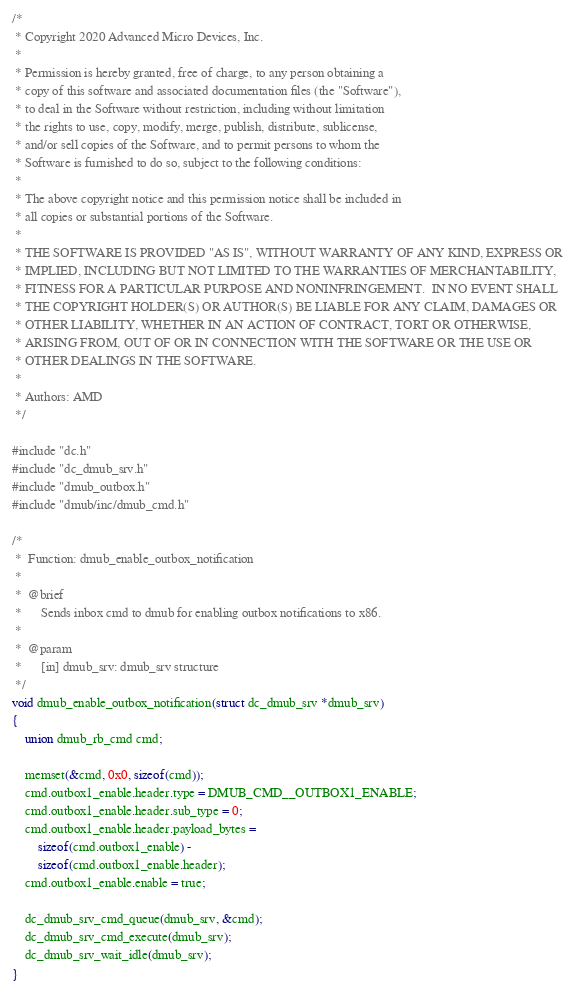<code> <loc_0><loc_0><loc_500><loc_500><_C_>/*
 * Copyright 2020 Advanced Micro Devices, Inc.
 *
 * Permission is hereby granted, free of charge, to any person obtaining a
 * copy of this software and associated documentation files (the "Software"),
 * to deal in the Software without restriction, including without limitation
 * the rights to use, copy, modify, merge, publish, distribute, sublicense,
 * and/or sell copies of the Software, and to permit persons to whom the
 * Software is furnished to do so, subject to the following conditions:
 *
 * The above copyright notice and this permission notice shall be included in
 * all copies or substantial portions of the Software.
 *
 * THE SOFTWARE IS PROVIDED "AS IS", WITHOUT WARRANTY OF ANY KIND, EXPRESS OR
 * IMPLIED, INCLUDING BUT NOT LIMITED TO THE WARRANTIES OF MERCHANTABILITY,
 * FITNESS FOR A PARTICULAR PURPOSE AND NONINFRINGEMENT.  IN NO EVENT SHALL
 * THE COPYRIGHT HOLDER(S) OR AUTHOR(S) BE LIABLE FOR ANY CLAIM, DAMAGES OR
 * OTHER LIABILITY, WHETHER IN AN ACTION OF CONTRACT, TORT OR OTHERWISE,
 * ARISING FROM, OUT OF OR IN CONNECTION WITH THE SOFTWARE OR THE USE OR
 * OTHER DEALINGS IN THE SOFTWARE.
 *
 * Authors: AMD
 */

#include "dc.h"
#include "dc_dmub_srv.h"
#include "dmub_outbox.h"
#include "dmub/inc/dmub_cmd.h"

/*
 *  Function: dmub_enable_outbox_notification
 *
 *  @brief
 *		Sends inbox cmd to dmub for enabling outbox notifications to x86.
 *
 *  @param
 *		[in] dmub_srv: dmub_srv structure
 */
void dmub_enable_outbox_notification(struct dc_dmub_srv *dmub_srv)
{
	union dmub_rb_cmd cmd;

	memset(&cmd, 0x0, sizeof(cmd));
	cmd.outbox1_enable.header.type = DMUB_CMD__OUTBOX1_ENABLE;
	cmd.outbox1_enable.header.sub_type = 0;
	cmd.outbox1_enable.header.payload_bytes =
		sizeof(cmd.outbox1_enable) -
		sizeof(cmd.outbox1_enable.header);
	cmd.outbox1_enable.enable = true;

	dc_dmub_srv_cmd_queue(dmub_srv, &cmd);
	dc_dmub_srv_cmd_execute(dmub_srv);
	dc_dmub_srv_wait_idle(dmub_srv);
}
</code> 